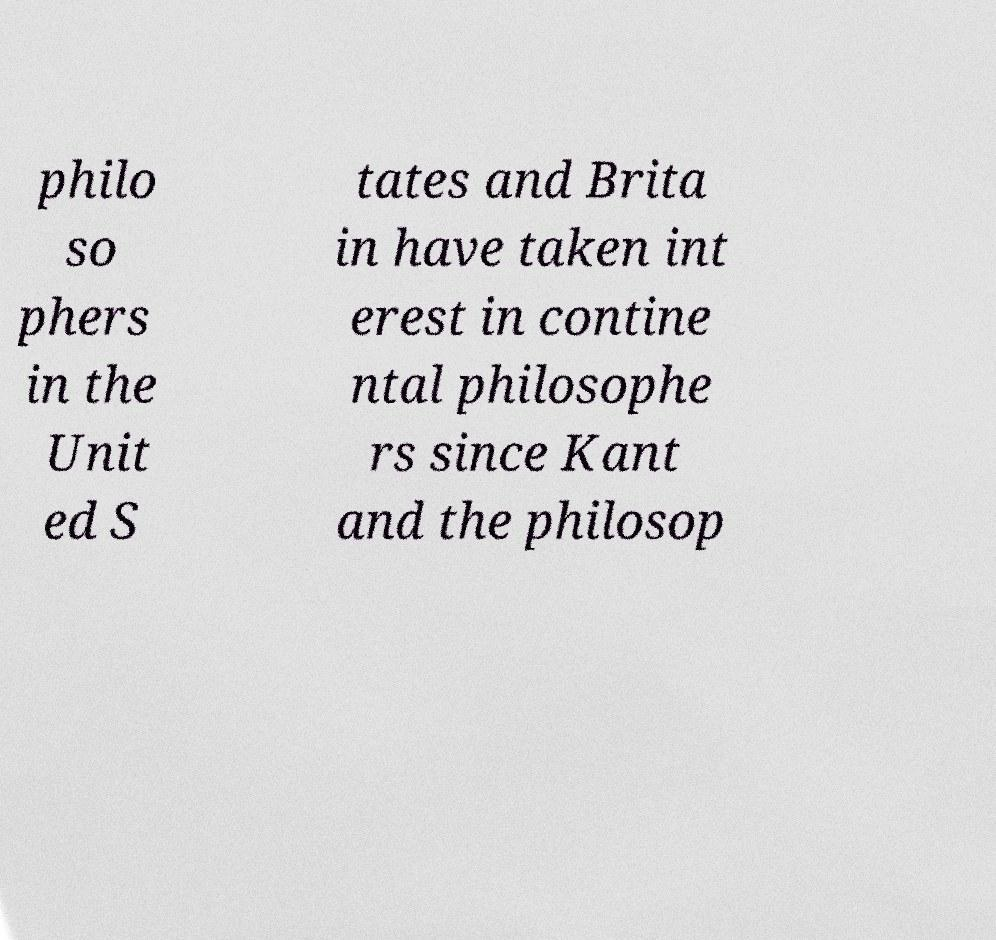What messages or text are displayed in this image? I need them in a readable, typed format. philo so phers in the Unit ed S tates and Brita in have taken int erest in contine ntal philosophe rs since Kant and the philosop 